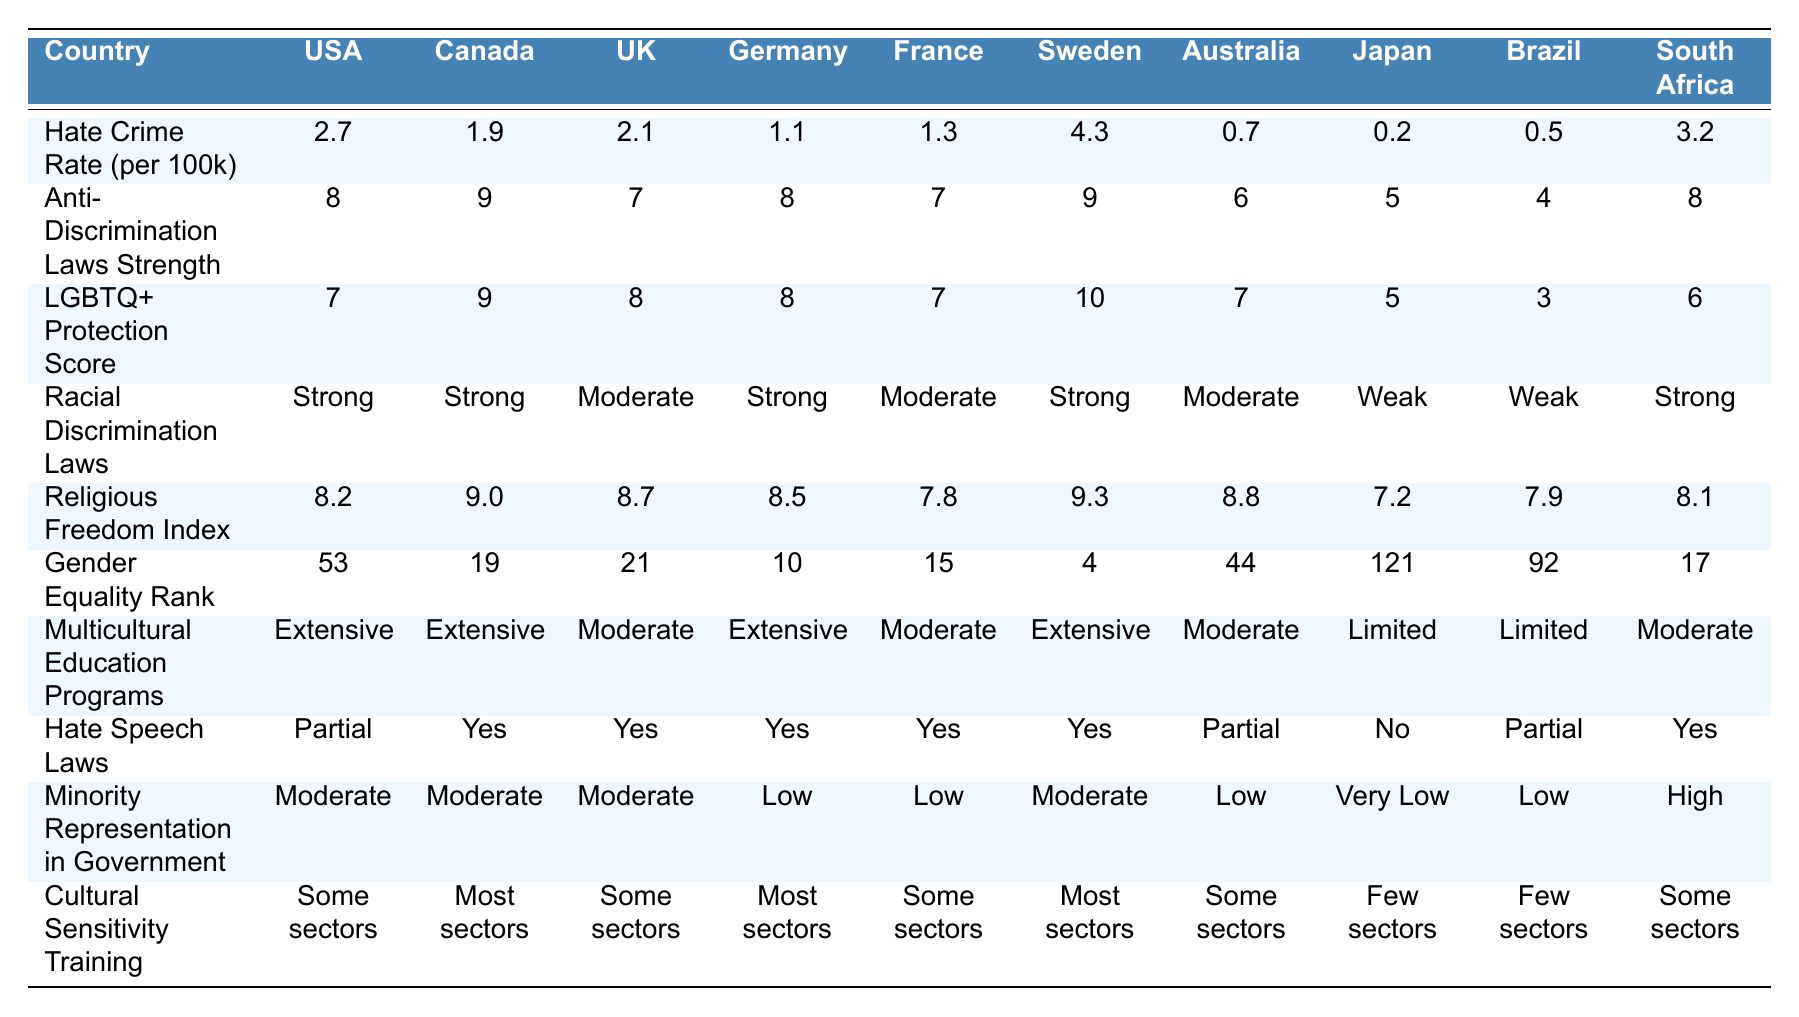What is the hate crime rate per 100,000 in Sweden? The table shows that the hate crime rate per 100,000 in Sweden is listed as 4.3.
Answer: 4.3 Which country has the highest LGBTQ+ protection score? By reviewing the LGBTQ+ protection scores in the table, Sweden has the highest score listed at 10.
Answer: Sweden How many countries have a hate crime rate above 2.0? The hate crime rates above 2.0 can be found by checking the rates. The countries are the United States (2.7), United Kingdom (2.1), and South Africa (3.2), totaling 3 countries.
Answer: 3 Is Canada’s anti-discrimination law strength higher than that of Japan? The anti-discrimination law strength for Canada is 9, while Japan's is 5. Since 9 is greater than 5, the statement is true.
Answer: Yes What is the average hate crime rate for the listed countries? To find the average, sum the hate crime rates: (2.7 + 1.9 + 2.1 + 1.1 + 1.3 + 4.3 + 0.7 + 0.2 + 0.5 + 3.2) = 19.1, then divide by the number of countries (10). Thus, the average is 19.1 / 10 = 1.91.
Answer: 1.91 Which country has the lowest gender equality rank? Looking at the gender equality ranks, Japan is listed with a rank of 121, which is the lowest among the countries shown in the table.
Answer: Japan Is there a correlation between hate crime rate and anti-discrimination law strength? To analyze the correlation, we compare the rates and strengths. The United States has a high hate crime rate (2.7) but a relatively strong anti-discrimination law (8), while countries like Canada with a lower hate crime rate (1.9) have a stronger law (9). This indicates there's not a clear, direct correlation.
Answer: No clear correlation How does the racial discrimination law in Brazil compare to that in South Africa? The table states that Brazil has weak racial discrimination laws while South Africa has strong laws. Therefore, South Africa's laws are significantly stronger than Brazil's.
Answer: South Africa has stronger laws Which countries have limited multicultural education programs? By checking the multicultural education programs, we see that Japan and Brazil are both listed with "Limited" programs.
Answer: Japan, Brazil Does Germany have hate speech laws? The table indicates that Germany has "Yes" listed for hate speech laws, confirming their existence.
Answer: Yes 